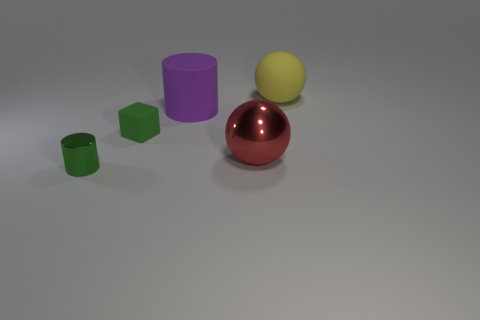Add 2 tiny green rubber cylinders. How many objects exist? 7 Subtract all balls. How many objects are left? 3 Subtract 0 brown blocks. How many objects are left? 5 Subtract all small green metallic cylinders. Subtract all large green objects. How many objects are left? 4 Add 3 yellow rubber objects. How many yellow rubber objects are left? 4 Add 3 tiny green matte things. How many tiny green matte things exist? 4 